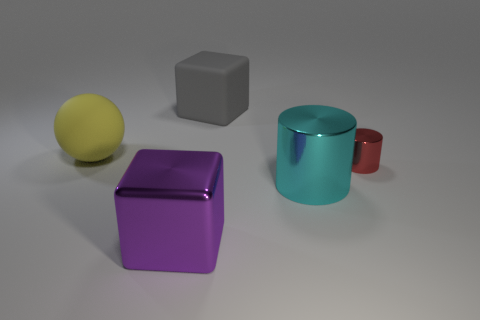There is a big object that is behind the rubber sphere; what number of yellow matte objects are on the right side of it?
Offer a very short reply. 0. There is a thing that is in front of the big yellow rubber thing and on the left side of the cyan thing; how big is it?
Offer a terse response. Large. There is a big thing that is behind the large yellow ball; what is it made of?
Offer a terse response. Rubber. Is there a tiny metal object of the same shape as the big yellow matte object?
Make the answer very short. No. What number of big cyan things are the same shape as the small shiny thing?
Your answer should be compact. 1. There is a metal thing on the right side of the cyan metal cylinder; is it the same size as the block that is in front of the small red cylinder?
Keep it short and to the point. No. What shape is the large thing on the right side of the large block that is behind the small red shiny cylinder?
Your response must be concise. Cylinder. Are there an equal number of red things that are in front of the purple block and large yellow things?
Your answer should be very brief. No. What is the material of the block behind the metallic object on the left side of the large thing that is behind the yellow rubber object?
Provide a short and direct response. Rubber. Are there any green matte cubes of the same size as the ball?
Your response must be concise. No. 